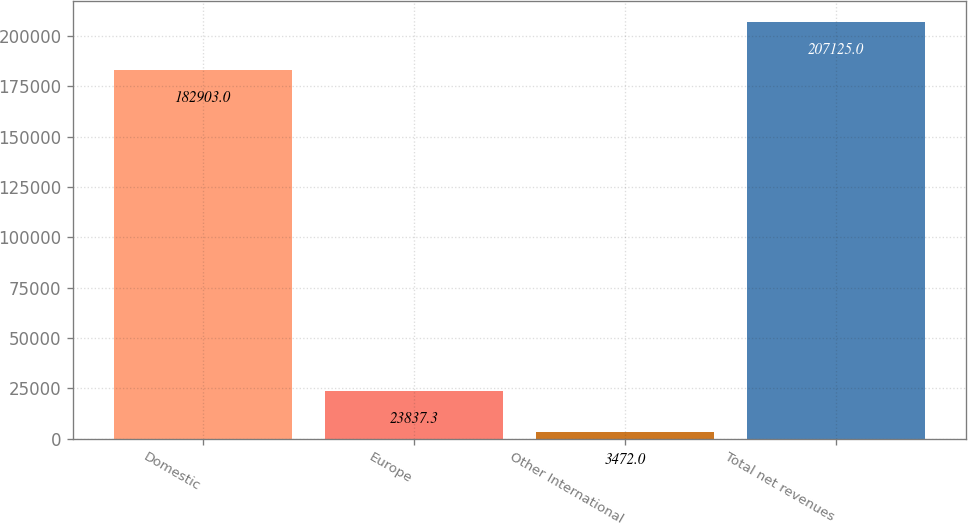Convert chart. <chart><loc_0><loc_0><loc_500><loc_500><bar_chart><fcel>Domestic<fcel>Europe<fcel>Other International<fcel>Total net revenues<nl><fcel>182903<fcel>23837.3<fcel>3472<fcel>207125<nl></chart> 